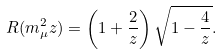<formula> <loc_0><loc_0><loc_500><loc_500>R ( m _ { \mu } ^ { 2 } z ) = \left ( 1 + \frac { 2 } { z } \right ) \sqrt { 1 - \frac { 4 } { z } } .</formula> 